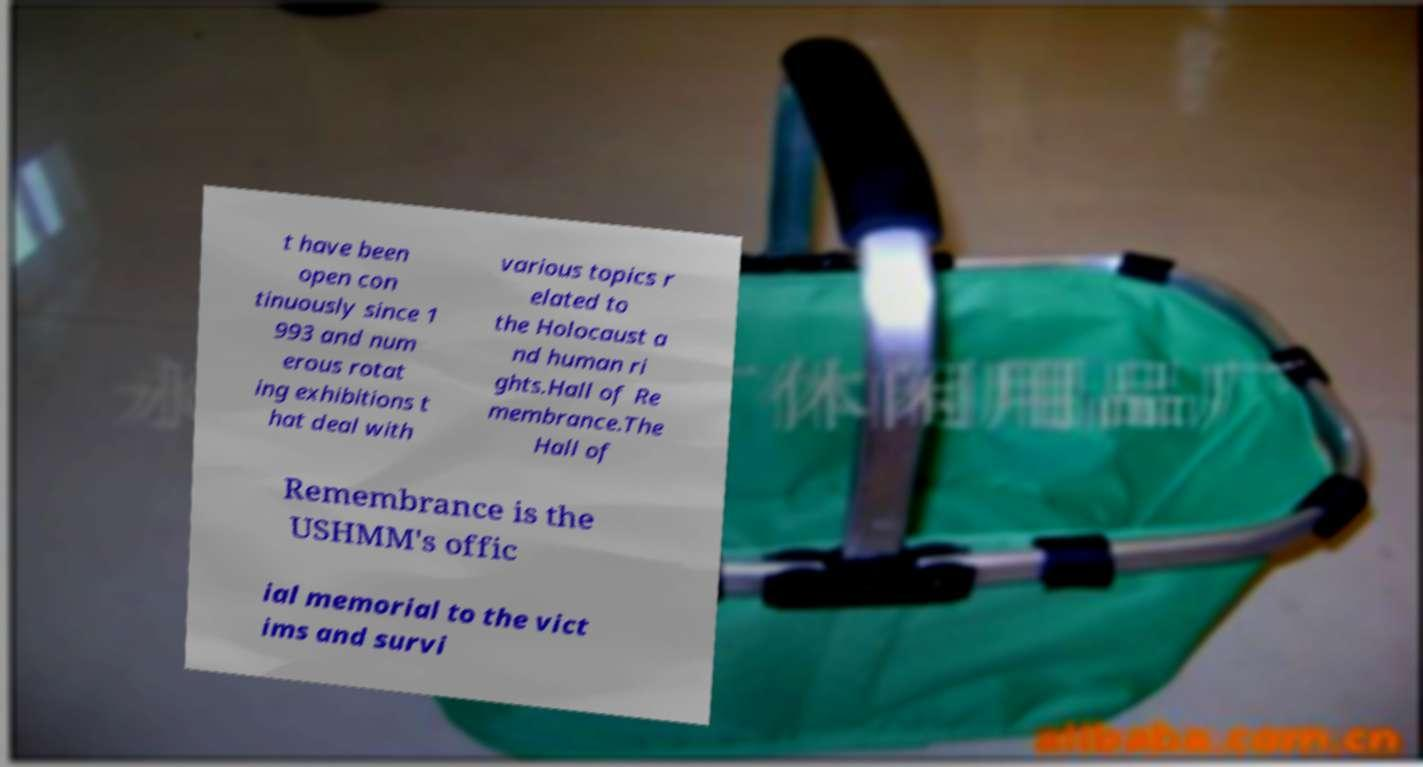Could you assist in decoding the text presented in this image and type it out clearly? t have been open con tinuously since 1 993 and num erous rotat ing exhibitions t hat deal with various topics r elated to the Holocaust a nd human ri ghts.Hall of Re membrance.The Hall of Remembrance is the USHMM's offic ial memorial to the vict ims and survi 